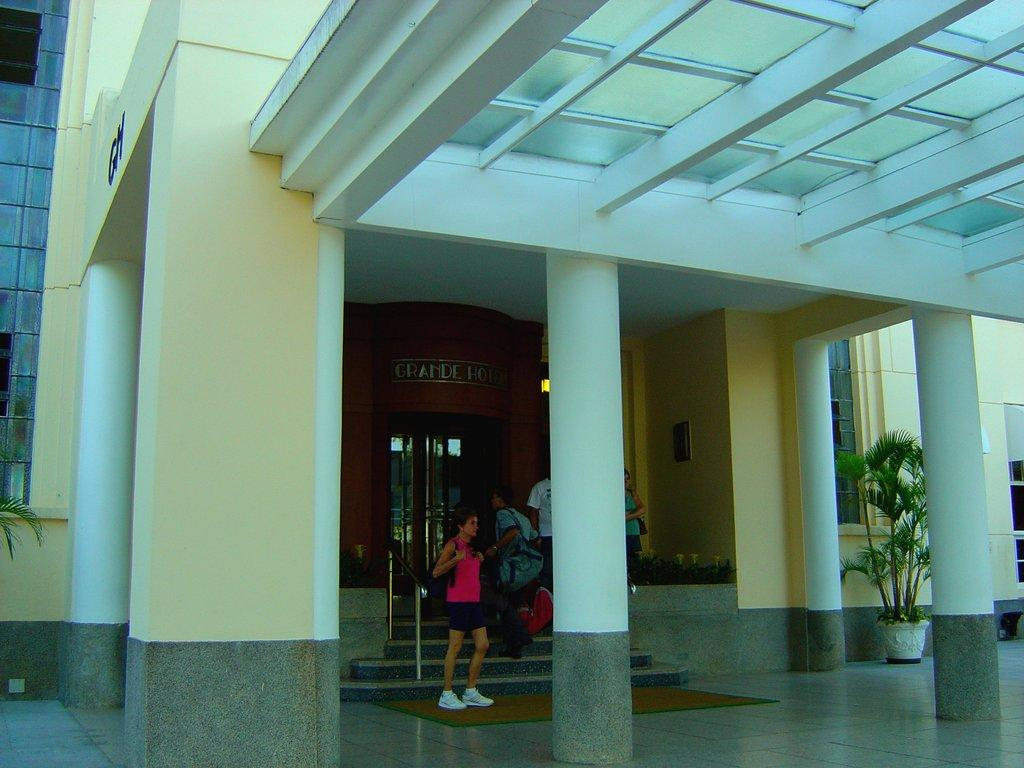What type of structure is visible in the image? There is a building in the image. What architectural features can be seen on the building? There are pillars, a door, a railing, a staircase, and windows visible on the building. What type of vegetation is present in the image? There are house plants in the image. Are there any people visible in the image? Yes, there are persons in the image. What is the condition of the road in the image? There is no road present in the image; it features a building with various architectural features and house plants. 